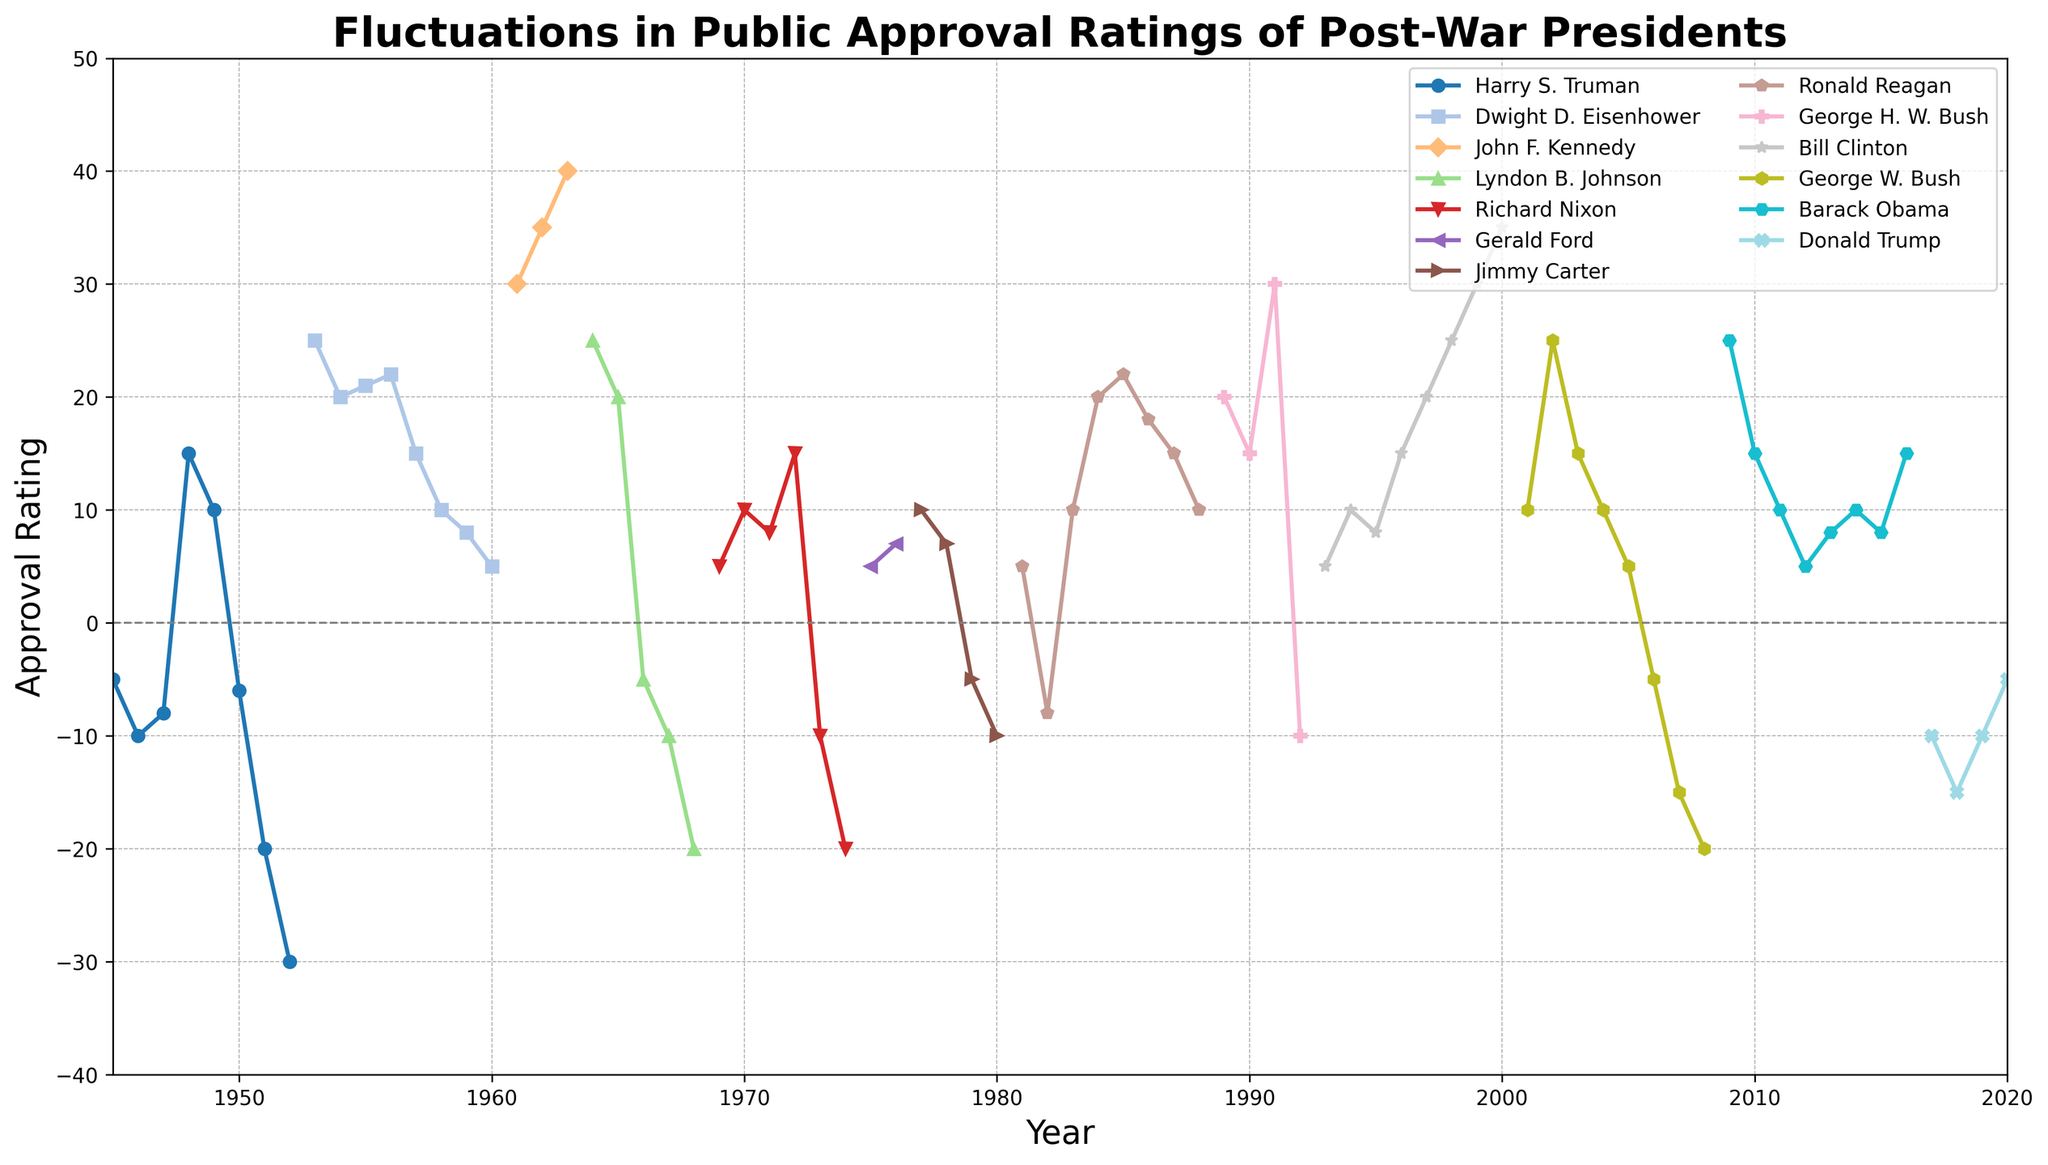Which president had the highest approval rating in a single year according to the chart? The highest point on the chart represents the highest approval rating, which corresponds to John F. Kennedy in 1963 at 40.
Answer: John F. Kennedy Which president experienced the most significant drop in approval rating from one year to the next? The steepest negative slope indicates the most significant drop. Harry S. Truman's approval dropped from 15 in 1948 to -6 in 1950, a difference of 21 points.
Answer: Harry S. Truman Between 2001 and 2008, how did the approval rating of George W. Bush change overall? George W. Bush's approval rating started at 10 in 2001, peaked at 25 in 2002, and then decreased to -20 by 2008. Adding all the changes: 10 to 25 (up 15), 25 to 15 (down 10), 15 to 10 (down 5), 10 to 5 (down 5), 5 to -5 (down 10), -5 to -15 (down 10), and -15 to -20 (down 5) totals a net decrease.
Answer: Decreased Compare the initial and final approval ratings of Ronald Reagan during his presidency. Ronald Reagan's initial approval rating in 1981 was 5, and his final approval rating in 1988 was 10. Subtract the initial from the final: 10 - 5.
Answer: Increased by 5 What was the general trend in the last four years of Lyndon B. Johnson’s presidency? In 1965, Johnson's approval was 20, and it decreased in the following years: 1966 (-5), 1967 (-10), and 1968 (-20). This shows a continuous downward trend.
Answer: Downward trend Calculate the average approval rating for Harry S. Truman from 1945 to 1952. Sum of the approval ratings for Harry S. Truman (-5, -10, -8, 15, 10, -6, -20, -30) is -54. The number of years is 8. Divide the sum by the number of years: -54 / 8.
Answer: -6.75 Identify the presidents who had any approval ratings below zero at any point during their term. By identifying points below the horizontal axis (approval rating of 0), the presidents with negative values are: Harry S. Truman, Lyndon B. Johnson, Richard Nixon, Jimmy Carter, Ronald Reagan, George H. W. Bush, George W. Bush, Donald Trump.
Answer: Truman, Johnson, Nixon, Carter, Reagan, G.H.W. Bush, G.W. Bush, Trump Which president showed the most consistency in their approval rating? The flattest line on the chart indicates consistency. Dwight D. Eisenhower's approval does not fluctuate significantly, with ratings mostly between 5 and 25 consistently.
Answer: Dwight D. Eisenhower Compare the approval ratings of Barack Obama in his first and last years in office. In 2009, Obama started with an approval rating of 25, and in 2016, his rating was 15. Subtracting the final year from the first year: 15 - 25.
Answer: Decreased by 10 